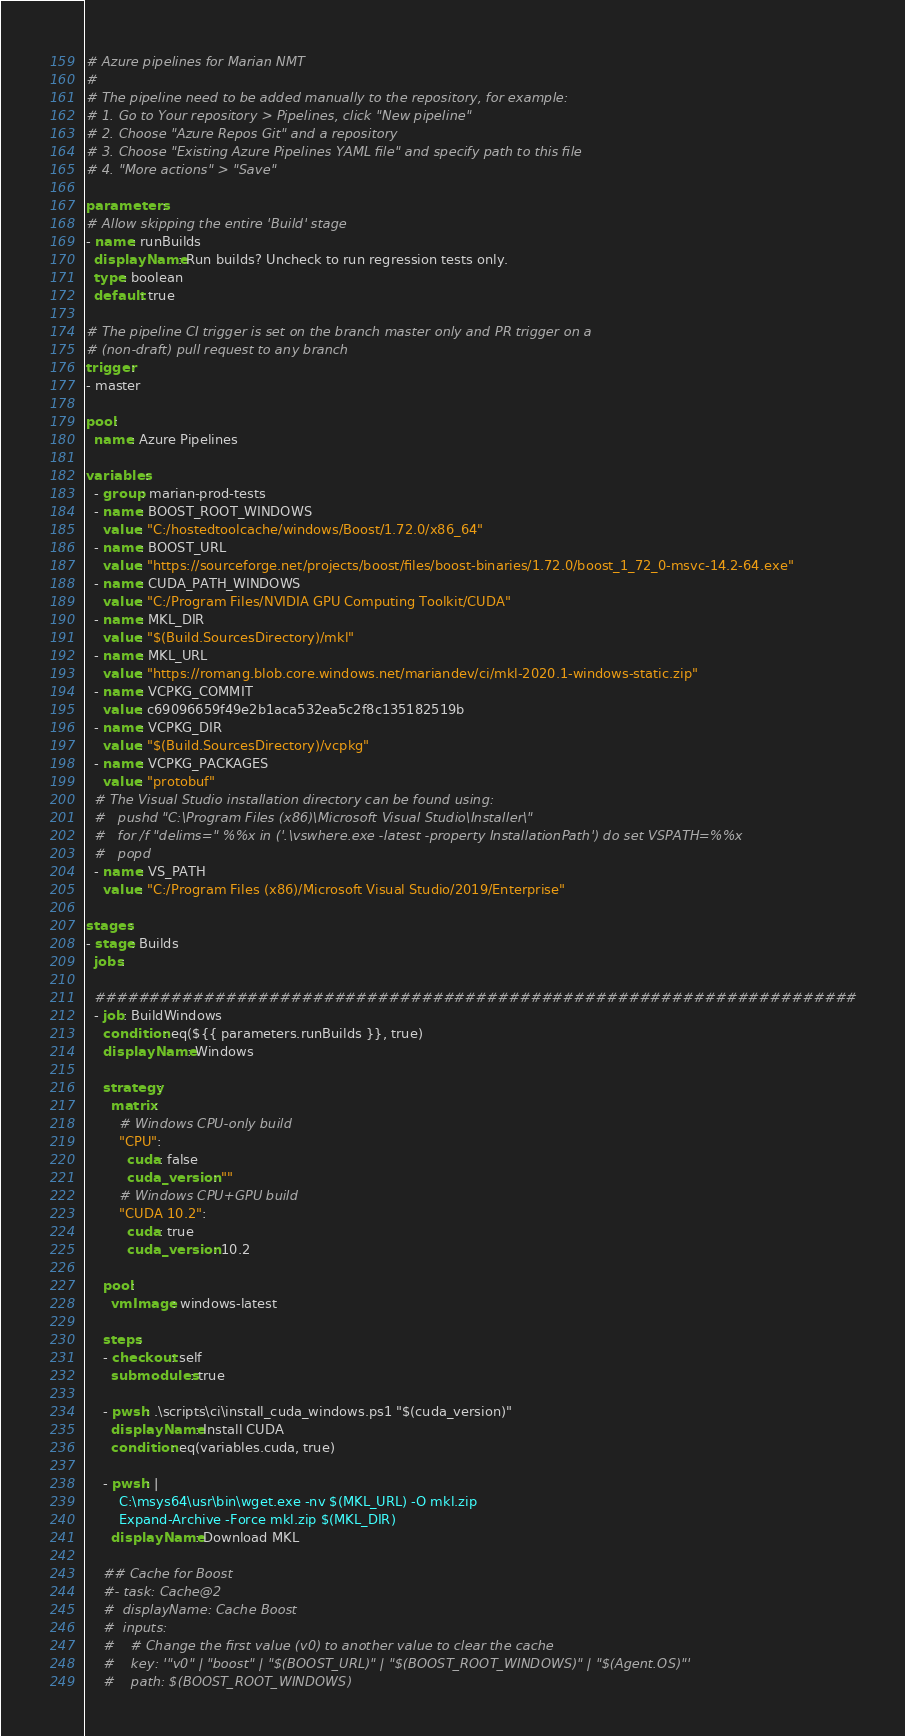Convert code to text. <code><loc_0><loc_0><loc_500><loc_500><_YAML_># Azure pipelines for Marian NMT
#
# The pipeline need to be added manually to the repository, for example:
# 1. Go to Your repository > Pipelines, click "New pipeline"
# 2. Choose "Azure Repos Git" and a repository
# 3. Choose "Existing Azure Pipelines YAML file" and specify path to this file
# 4. "More actions" > "Save"

parameters:
# Allow skipping the entire 'Build' stage
- name: runBuilds
  displayName: Run builds? Uncheck to run regression tests only.
  type: boolean
  default: true

# The pipeline CI trigger is set on the branch master only and PR trigger on a
# (non-draft) pull request to any branch
trigger:
- master

pool:
  name: Azure Pipelines

variables:
  - group: marian-prod-tests
  - name: BOOST_ROOT_WINDOWS
    value: "C:/hostedtoolcache/windows/Boost/1.72.0/x86_64"
  - name: BOOST_URL
    value: "https://sourceforge.net/projects/boost/files/boost-binaries/1.72.0/boost_1_72_0-msvc-14.2-64.exe"
  - name: CUDA_PATH_WINDOWS
    value: "C:/Program Files/NVIDIA GPU Computing Toolkit/CUDA"
  - name: MKL_DIR
    value: "$(Build.SourcesDirectory)/mkl"
  - name: MKL_URL
    value: "https://romang.blob.core.windows.net/mariandev/ci/mkl-2020.1-windows-static.zip"
  - name: VCPKG_COMMIT
    value: c69096659f49e2b1aca532ea5c2f8c135182519b
  - name: VCPKG_DIR
    value: "$(Build.SourcesDirectory)/vcpkg"
  - name: VCPKG_PACKAGES
    value: "protobuf"
  # The Visual Studio installation directory can be found using:
  #   pushd "C:\Program Files (x86)\Microsoft Visual Studio\Installer\"
  #   for /f "delims=" %%x in ('.\vswhere.exe -latest -property InstallationPath') do set VSPATH=%%x
  #   popd
  - name: VS_PATH
    value: "C:/Program Files (x86)/Microsoft Visual Studio/2019/Enterprise"

stages:
- stage: Builds
  jobs:

  ######################################################################
  - job: BuildWindows
    condition: eq(${{ parameters.runBuilds }}, true)
    displayName: Windows

    strategy:
      matrix:
        # Windows CPU-only build
        "CPU":
          cuda: false
          cuda_version: ""
        # Windows CPU+GPU build
        "CUDA 10.2":
          cuda: true
          cuda_version: 10.2

    pool:
      vmImage: windows-latest

    steps:
    - checkout: self
      submodules: true

    - pwsh: .\scripts\ci\install_cuda_windows.ps1 "$(cuda_version)"
      displayName: Install CUDA
      condition: eq(variables.cuda, true)

    - pwsh: |
        C:\msys64\usr\bin\wget.exe -nv $(MKL_URL) -O mkl.zip
        Expand-Archive -Force mkl.zip $(MKL_DIR)
      displayName: Download MKL

    ## Cache for Boost
    #- task: Cache@2
    #  displayName: Cache Boost
    #  inputs:
    #    # Change the first value (v0) to another value to clear the cache
    #    key: '"v0" | "boost" | "$(BOOST_URL)" | "$(BOOST_ROOT_WINDOWS)" | "$(Agent.OS)"'
    #    path: $(BOOST_ROOT_WINDOWS)</code> 